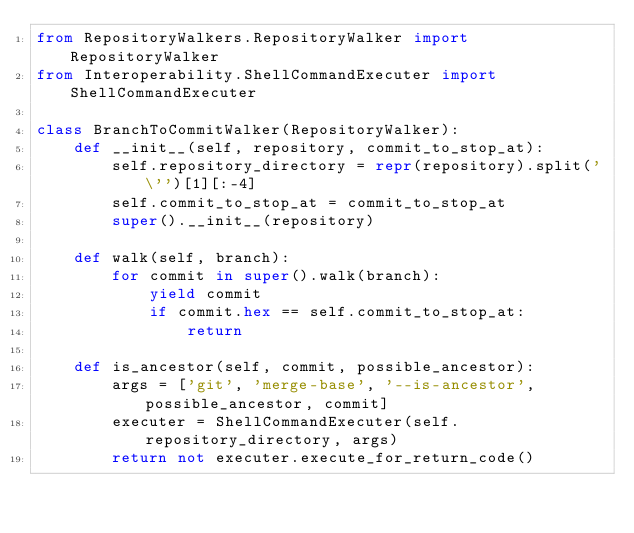Convert code to text. <code><loc_0><loc_0><loc_500><loc_500><_Python_>from RepositoryWalkers.RepositoryWalker import RepositoryWalker
from Interoperability.ShellCommandExecuter import ShellCommandExecuter

class BranchToCommitWalker(RepositoryWalker):
    def __init__(self, repository, commit_to_stop_at):
        self.repository_directory = repr(repository).split('\'')[1][:-4]
        self.commit_to_stop_at = commit_to_stop_at
        super().__init__(repository)

    def walk(self, branch):
        for commit in super().walk(branch):
            yield commit
            if commit.hex == self.commit_to_stop_at:
                return

    def is_ancestor(self, commit, possible_ancestor):
        args = ['git', 'merge-base', '--is-ancestor', possible_ancestor, commit]
        executer = ShellCommandExecuter(self.repository_directory, args)
        return not executer.execute_for_return_code()</code> 